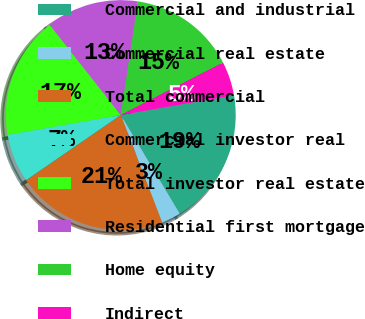<chart> <loc_0><loc_0><loc_500><loc_500><pie_chart><fcel>Commercial and industrial<fcel>Commercial real estate<fcel>Total commercial<fcel>Commercial investor real<fcel>Total investor real estate<fcel>Residential first mortgage<fcel>Home equity<fcel>Indirect<nl><fcel>19.19%<fcel>2.72%<fcel>21.25%<fcel>6.84%<fcel>17.13%<fcel>13.01%<fcel>15.07%<fcel>4.78%<nl></chart> 